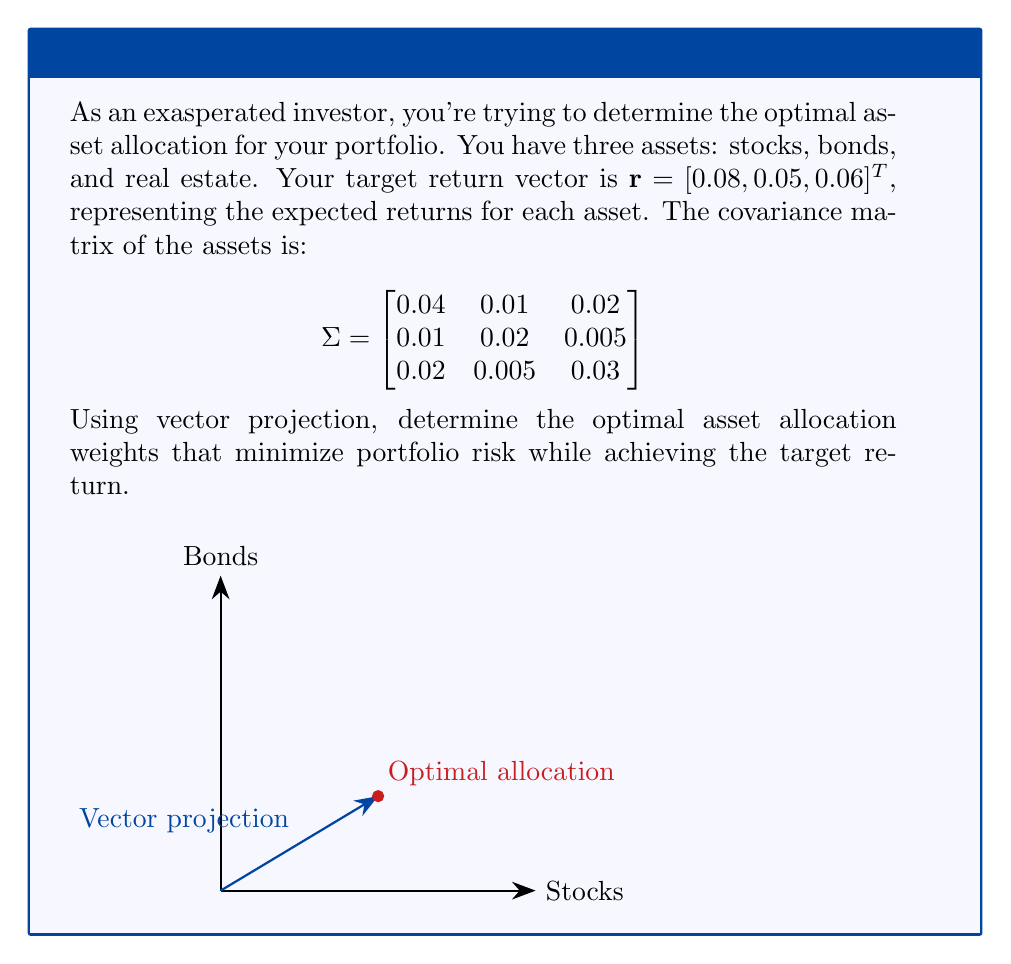Can you answer this question? To solve this problem, we'll use the concept of vector projection in the context of portfolio optimization. Here's a step-by-step approach:

1) First, we need to calculate the inverse of the covariance matrix $\Sigma^{-1}$:

   $$\Sigma^{-1} = \begin{bmatrix}
   31.25 & -12.5 & -16.67 \\
   -12.5 & 58.33 & -4.17 \\
   -16.67 & -4.17 & 41.67
   \end{bmatrix}$$

2) The optimal asset allocation weights are given by the formula:

   $$\mathbf{w} = \frac{\Sigma^{-1}\mathbf{r}}{\mathbf{1}^T\Sigma^{-1}\mathbf{r}}$$

   where $\mathbf{1}$ is a vector of ones.

3) Let's calculate $\Sigma^{-1}\mathbf{r}$:

   $$\Sigma^{-1}\mathbf{r} = \begin{bmatrix}
   31.25 & -12.5 & -16.67 \\
   -12.5 & 58.33 & -4.17 \\
   -16.67 & -4.17 & 41.67
   \end{bmatrix} \begin{bmatrix}
   0.08 \\
   0.05 \\
   0.06
   \end{bmatrix} = \begin{bmatrix}
   1.25 \\
   2.08 \\
   1.67
   \end{bmatrix}$$

4) Now, let's calculate $\mathbf{1}^T\Sigma^{-1}\mathbf{r}$:

   $$\mathbf{1}^T\Sigma^{-1}\mathbf{r} = [1, 1, 1] \begin{bmatrix}
   1.25 \\
   2.08 \\
   1.67
   \end{bmatrix} = 5$$

5) Finally, we can calculate the optimal weights:

   $$\mathbf{w} = \frac{1}{5} \begin{bmatrix}
   1.25 \\
   2.08 \\
   1.67
   \end{bmatrix} = \begin{bmatrix}
   0.25 \\
   0.416 \\
   0.334
   \end{bmatrix}$$

These weights represent the optimal asset allocation that minimizes portfolio risk while achieving the target return.
Answer: $\mathbf{w} = [0.25, 0.416, 0.334]^T$ 